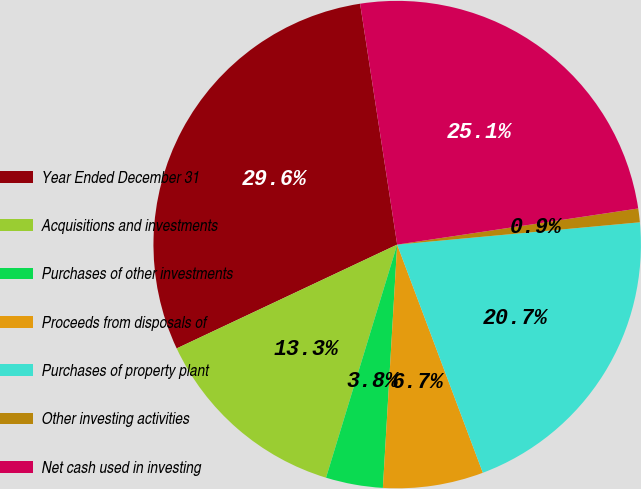Convert chart. <chart><loc_0><loc_0><loc_500><loc_500><pie_chart><fcel>Year Ended December 31<fcel>Acquisitions and investments<fcel>Purchases of other investments<fcel>Proceeds from disposals of<fcel>Purchases of property plant<fcel>Other investing activities<fcel>Net cash used in investing<nl><fcel>29.57%<fcel>13.28%<fcel>3.78%<fcel>6.65%<fcel>20.74%<fcel>0.91%<fcel>25.06%<nl></chart> 